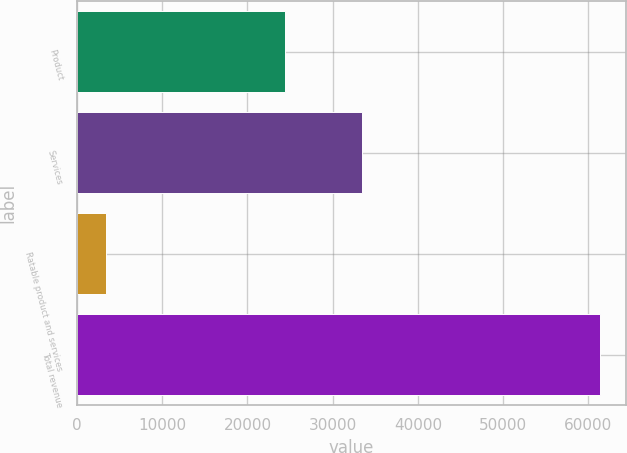Convert chart. <chart><loc_0><loc_0><loc_500><loc_500><bar_chart><fcel>Product<fcel>Services<fcel>Ratable product and services<fcel>Total revenue<nl><fcel>24451<fcel>33473<fcel>3421<fcel>61345<nl></chart> 